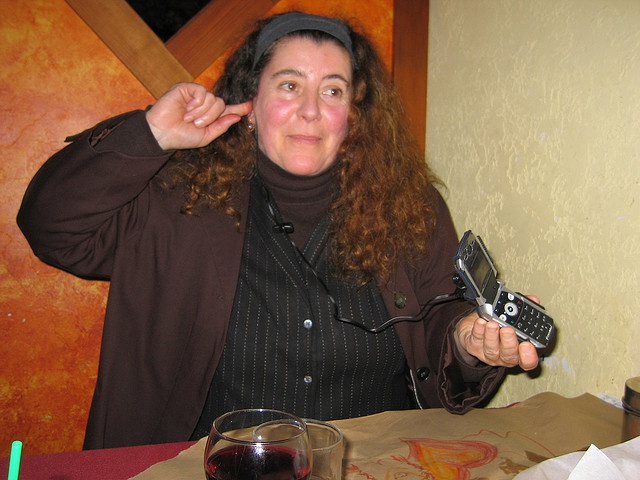Describe the objects in this image and their specific colors. I can see people in brown, black, maroon, and salmon tones, dining table in brown, olive, and maroon tones, wine glass in brown, black, maroon, and gray tones, cell phone in brown, black, gray, darkgray, and darkgreen tones, and cup in brown, gray, and maroon tones in this image. 